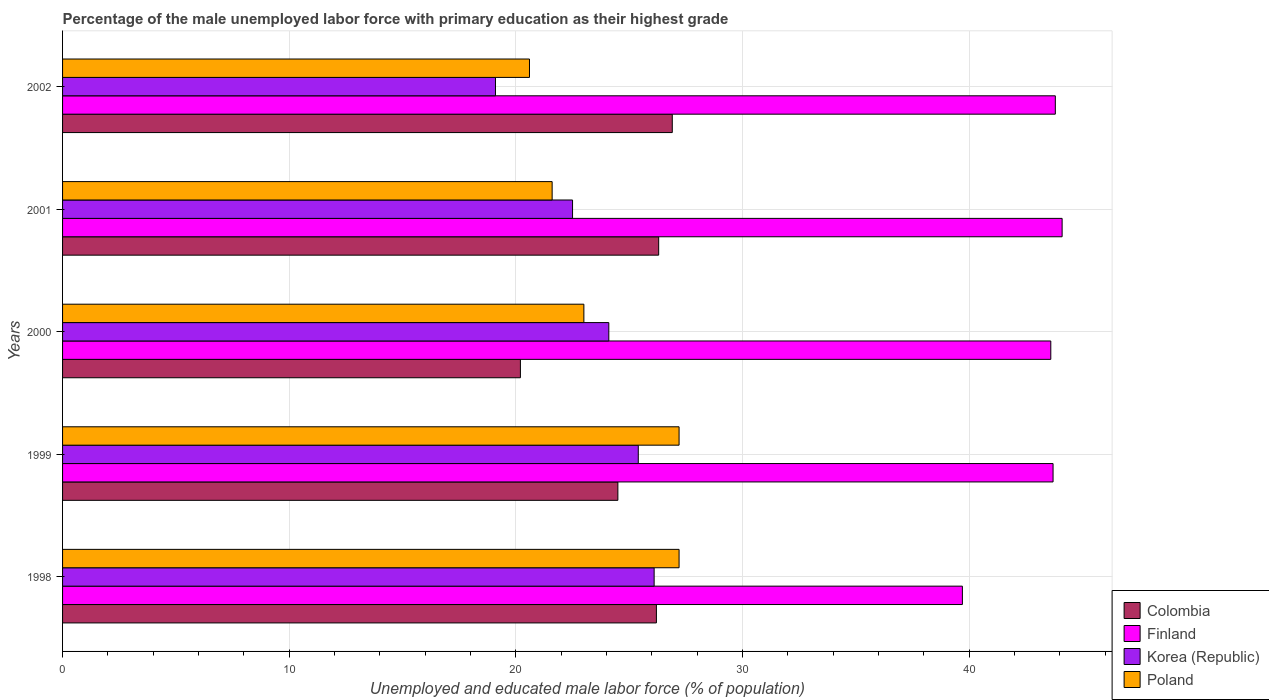Are the number of bars per tick equal to the number of legend labels?
Offer a terse response. Yes. Are the number of bars on each tick of the Y-axis equal?
Provide a succinct answer. Yes. How many bars are there on the 3rd tick from the top?
Your response must be concise. 4. What is the percentage of the unemployed male labor force with primary education in Korea (Republic) in 1998?
Provide a succinct answer. 26.1. Across all years, what is the maximum percentage of the unemployed male labor force with primary education in Finland?
Ensure brevity in your answer.  44.1. Across all years, what is the minimum percentage of the unemployed male labor force with primary education in Colombia?
Give a very brief answer. 20.2. What is the total percentage of the unemployed male labor force with primary education in Colombia in the graph?
Ensure brevity in your answer.  124.1. What is the difference between the percentage of the unemployed male labor force with primary education in Poland in 2000 and that in 2002?
Provide a succinct answer. 2.4. What is the difference between the percentage of the unemployed male labor force with primary education in Poland in 2000 and the percentage of the unemployed male labor force with primary education in Finland in 2002?
Your response must be concise. -20.8. What is the average percentage of the unemployed male labor force with primary education in Finland per year?
Provide a succinct answer. 42.98. In the year 2002, what is the difference between the percentage of the unemployed male labor force with primary education in Colombia and percentage of the unemployed male labor force with primary education in Finland?
Offer a terse response. -16.9. In how many years, is the percentage of the unemployed male labor force with primary education in Poland greater than 2 %?
Ensure brevity in your answer.  5. What is the ratio of the percentage of the unemployed male labor force with primary education in Poland in 1999 to that in 2002?
Your response must be concise. 1.32. Is the difference between the percentage of the unemployed male labor force with primary education in Colombia in 1999 and 2000 greater than the difference between the percentage of the unemployed male labor force with primary education in Finland in 1999 and 2000?
Offer a very short reply. Yes. What is the difference between the highest and the second highest percentage of the unemployed male labor force with primary education in Poland?
Your answer should be very brief. 0. What is the difference between the highest and the lowest percentage of the unemployed male labor force with primary education in Finland?
Your answer should be compact. 4.4. What does the 3rd bar from the bottom in 1998 represents?
Offer a very short reply. Korea (Republic). Is it the case that in every year, the sum of the percentage of the unemployed male labor force with primary education in Colombia and percentage of the unemployed male labor force with primary education in Korea (Republic) is greater than the percentage of the unemployed male labor force with primary education in Poland?
Your answer should be compact. Yes. How many bars are there?
Your answer should be compact. 20. Are all the bars in the graph horizontal?
Your answer should be compact. Yes. How many years are there in the graph?
Provide a succinct answer. 5. What is the difference between two consecutive major ticks on the X-axis?
Ensure brevity in your answer.  10. Does the graph contain any zero values?
Your answer should be compact. No. What is the title of the graph?
Your answer should be compact. Percentage of the male unemployed labor force with primary education as their highest grade. Does "Latvia" appear as one of the legend labels in the graph?
Make the answer very short. No. What is the label or title of the X-axis?
Make the answer very short. Unemployed and educated male labor force (% of population). What is the Unemployed and educated male labor force (% of population) in Colombia in 1998?
Provide a short and direct response. 26.2. What is the Unemployed and educated male labor force (% of population) in Finland in 1998?
Give a very brief answer. 39.7. What is the Unemployed and educated male labor force (% of population) in Korea (Republic) in 1998?
Keep it short and to the point. 26.1. What is the Unemployed and educated male labor force (% of population) in Poland in 1998?
Offer a very short reply. 27.2. What is the Unemployed and educated male labor force (% of population) of Finland in 1999?
Your response must be concise. 43.7. What is the Unemployed and educated male labor force (% of population) in Korea (Republic) in 1999?
Your answer should be very brief. 25.4. What is the Unemployed and educated male labor force (% of population) in Poland in 1999?
Your answer should be very brief. 27.2. What is the Unemployed and educated male labor force (% of population) of Colombia in 2000?
Provide a short and direct response. 20.2. What is the Unemployed and educated male labor force (% of population) of Finland in 2000?
Offer a terse response. 43.6. What is the Unemployed and educated male labor force (% of population) in Korea (Republic) in 2000?
Make the answer very short. 24.1. What is the Unemployed and educated male labor force (% of population) in Colombia in 2001?
Your answer should be compact. 26.3. What is the Unemployed and educated male labor force (% of population) in Finland in 2001?
Keep it short and to the point. 44.1. What is the Unemployed and educated male labor force (% of population) of Korea (Republic) in 2001?
Give a very brief answer. 22.5. What is the Unemployed and educated male labor force (% of population) in Poland in 2001?
Your response must be concise. 21.6. What is the Unemployed and educated male labor force (% of population) of Colombia in 2002?
Your answer should be very brief. 26.9. What is the Unemployed and educated male labor force (% of population) in Finland in 2002?
Your answer should be very brief. 43.8. What is the Unemployed and educated male labor force (% of population) in Korea (Republic) in 2002?
Your answer should be very brief. 19.1. What is the Unemployed and educated male labor force (% of population) of Poland in 2002?
Keep it short and to the point. 20.6. Across all years, what is the maximum Unemployed and educated male labor force (% of population) of Colombia?
Offer a terse response. 26.9. Across all years, what is the maximum Unemployed and educated male labor force (% of population) of Finland?
Offer a very short reply. 44.1. Across all years, what is the maximum Unemployed and educated male labor force (% of population) in Korea (Republic)?
Provide a succinct answer. 26.1. Across all years, what is the maximum Unemployed and educated male labor force (% of population) of Poland?
Your answer should be compact. 27.2. Across all years, what is the minimum Unemployed and educated male labor force (% of population) of Colombia?
Provide a succinct answer. 20.2. Across all years, what is the minimum Unemployed and educated male labor force (% of population) in Finland?
Make the answer very short. 39.7. Across all years, what is the minimum Unemployed and educated male labor force (% of population) of Korea (Republic)?
Ensure brevity in your answer.  19.1. Across all years, what is the minimum Unemployed and educated male labor force (% of population) of Poland?
Your answer should be compact. 20.6. What is the total Unemployed and educated male labor force (% of population) in Colombia in the graph?
Provide a succinct answer. 124.1. What is the total Unemployed and educated male labor force (% of population) in Finland in the graph?
Give a very brief answer. 214.9. What is the total Unemployed and educated male labor force (% of population) of Korea (Republic) in the graph?
Offer a terse response. 117.2. What is the total Unemployed and educated male labor force (% of population) of Poland in the graph?
Provide a succinct answer. 119.6. What is the difference between the Unemployed and educated male labor force (% of population) in Korea (Republic) in 1998 and that in 1999?
Give a very brief answer. 0.7. What is the difference between the Unemployed and educated male labor force (% of population) of Poland in 1998 and that in 1999?
Your answer should be compact. 0. What is the difference between the Unemployed and educated male labor force (% of population) of Colombia in 1998 and that in 2000?
Your answer should be compact. 6. What is the difference between the Unemployed and educated male labor force (% of population) in Korea (Republic) in 1998 and that in 2000?
Provide a succinct answer. 2. What is the difference between the Unemployed and educated male labor force (% of population) in Poland in 1998 and that in 2000?
Your answer should be very brief. 4.2. What is the difference between the Unemployed and educated male labor force (% of population) of Colombia in 1998 and that in 2001?
Ensure brevity in your answer.  -0.1. What is the difference between the Unemployed and educated male labor force (% of population) in Finland in 1998 and that in 2001?
Your answer should be very brief. -4.4. What is the difference between the Unemployed and educated male labor force (% of population) in Korea (Republic) in 1998 and that in 2001?
Offer a terse response. 3.6. What is the difference between the Unemployed and educated male labor force (% of population) of Poland in 1998 and that in 2001?
Make the answer very short. 5.6. What is the difference between the Unemployed and educated male labor force (% of population) of Poland in 1998 and that in 2002?
Provide a short and direct response. 6.6. What is the difference between the Unemployed and educated male labor force (% of population) of Finland in 1999 and that in 2000?
Provide a succinct answer. 0.1. What is the difference between the Unemployed and educated male labor force (% of population) in Colombia in 1999 and that in 2001?
Keep it short and to the point. -1.8. What is the difference between the Unemployed and educated male labor force (% of population) in Poland in 1999 and that in 2001?
Your response must be concise. 5.6. What is the difference between the Unemployed and educated male labor force (% of population) in Korea (Republic) in 1999 and that in 2002?
Your answer should be very brief. 6.3. What is the difference between the Unemployed and educated male labor force (% of population) in Colombia in 2000 and that in 2001?
Give a very brief answer. -6.1. What is the difference between the Unemployed and educated male labor force (% of population) of Finland in 2000 and that in 2001?
Keep it short and to the point. -0.5. What is the difference between the Unemployed and educated male labor force (% of population) of Poland in 2000 and that in 2001?
Offer a very short reply. 1.4. What is the difference between the Unemployed and educated male labor force (% of population) in Colombia in 2000 and that in 2002?
Ensure brevity in your answer.  -6.7. What is the difference between the Unemployed and educated male labor force (% of population) in Poland in 2001 and that in 2002?
Your response must be concise. 1. What is the difference between the Unemployed and educated male labor force (% of population) in Colombia in 1998 and the Unemployed and educated male labor force (% of population) in Finland in 1999?
Your answer should be compact. -17.5. What is the difference between the Unemployed and educated male labor force (% of population) of Colombia in 1998 and the Unemployed and educated male labor force (% of population) of Korea (Republic) in 1999?
Make the answer very short. 0.8. What is the difference between the Unemployed and educated male labor force (% of population) of Finland in 1998 and the Unemployed and educated male labor force (% of population) of Korea (Republic) in 1999?
Your answer should be compact. 14.3. What is the difference between the Unemployed and educated male labor force (% of population) of Finland in 1998 and the Unemployed and educated male labor force (% of population) of Poland in 1999?
Give a very brief answer. 12.5. What is the difference between the Unemployed and educated male labor force (% of population) of Korea (Republic) in 1998 and the Unemployed and educated male labor force (% of population) of Poland in 1999?
Give a very brief answer. -1.1. What is the difference between the Unemployed and educated male labor force (% of population) of Colombia in 1998 and the Unemployed and educated male labor force (% of population) of Finland in 2000?
Offer a terse response. -17.4. What is the difference between the Unemployed and educated male labor force (% of population) in Colombia in 1998 and the Unemployed and educated male labor force (% of population) in Korea (Republic) in 2000?
Offer a terse response. 2.1. What is the difference between the Unemployed and educated male labor force (% of population) in Colombia in 1998 and the Unemployed and educated male labor force (% of population) in Poland in 2000?
Keep it short and to the point. 3.2. What is the difference between the Unemployed and educated male labor force (% of population) of Finland in 1998 and the Unemployed and educated male labor force (% of population) of Korea (Republic) in 2000?
Provide a short and direct response. 15.6. What is the difference between the Unemployed and educated male labor force (% of population) in Finland in 1998 and the Unemployed and educated male labor force (% of population) in Poland in 2000?
Give a very brief answer. 16.7. What is the difference between the Unemployed and educated male labor force (% of population) in Korea (Republic) in 1998 and the Unemployed and educated male labor force (% of population) in Poland in 2000?
Keep it short and to the point. 3.1. What is the difference between the Unemployed and educated male labor force (% of population) of Colombia in 1998 and the Unemployed and educated male labor force (% of population) of Finland in 2001?
Make the answer very short. -17.9. What is the difference between the Unemployed and educated male labor force (% of population) of Colombia in 1998 and the Unemployed and educated male labor force (% of population) of Korea (Republic) in 2001?
Your answer should be compact. 3.7. What is the difference between the Unemployed and educated male labor force (% of population) of Finland in 1998 and the Unemployed and educated male labor force (% of population) of Korea (Republic) in 2001?
Give a very brief answer. 17.2. What is the difference between the Unemployed and educated male labor force (% of population) in Colombia in 1998 and the Unemployed and educated male labor force (% of population) in Finland in 2002?
Your answer should be compact. -17.6. What is the difference between the Unemployed and educated male labor force (% of population) in Colombia in 1998 and the Unemployed and educated male labor force (% of population) in Poland in 2002?
Keep it short and to the point. 5.6. What is the difference between the Unemployed and educated male labor force (% of population) in Finland in 1998 and the Unemployed and educated male labor force (% of population) in Korea (Republic) in 2002?
Offer a very short reply. 20.6. What is the difference between the Unemployed and educated male labor force (% of population) in Finland in 1998 and the Unemployed and educated male labor force (% of population) in Poland in 2002?
Keep it short and to the point. 19.1. What is the difference between the Unemployed and educated male labor force (% of population) in Korea (Republic) in 1998 and the Unemployed and educated male labor force (% of population) in Poland in 2002?
Make the answer very short. 5.5. What is the difference between the Unemployed and educated male labor force (% of population) of Colombia in 1999 and the Unemployed and educated male labor force (% of population) of Finland in 2000?
Ensure brevity in your answer.  -19.1. What is the difference between the Unemployed and educated male labor force (% of population) in Colombia in 1999 and the Unemployed and educated male labor force (% of population) in Korea (Republic) in 2000?
Ensure brevity in your answer.  0.4. What is the difference between the Unemployed and educated male labor force (% of population) in Finland in 1999 and the Unemployed and educated male labor force (% of population) in Korea (Republic) in 2000?
Offer a very short reply. 19.6. What is the difference between the Unemployed and educated male labor force (% of population) of Finland in 1999 and the Unemployed and educated male labor force (% of population) of Poland in 2000?
Offer a terse response. 20.7. What is the difference between the Unemployed and educated male labor force (% of population) of Korea (Republic) in 1999 and the Unemployed and educated male labor force (% of population) of Poland in 2000?
Make the answer very short. 2.4. What is the difference between the Unemployed and educated male labor force (% of population) of Colombia in 1999 and the Unemployed and educated male labor force (% of population) of Finland in 2001?
Provide a short and direct response. -19.6. What is the difference between the Unemployed and educated male labor force (% of population) of Colombia in 1999 and the Unemployed and educated male labor force (% of population) of Poland in 2001?
Offer a very short reply. 2.9. What is the difference between the Unemployed and educated male labor force (% of population) of Finland in 1999 and the Unemployed and educated male labor force (% of population) of Korea (Republic) in 2001?
Make the answer very short. 21.2. What is the difference between the Unemployed and educated male labor force (% of population) in Finland in 1999 and the Unemployed and educated male labor force (% of population) in Poland in 2001?
Your response must be concise. 22.1. What is the difference between the Unemployed and educated male labor force (% of population) of Colombia in 1999 and the Unemployed and educated male labor force (% of population) of Finland in 2002?
Provide a short and direct response. -19.3. What is the difference between the Unemployed and educated male labor force (% of population) of Colombia in 1999 and the Unemployed and educated male labor force (% of population) of Korea (Republic) in 2002?
Keep it short and to the point. 5.4. What is the difference between the Unemployed and educated male labor force (% of population) of Finland in 1999 and the Unemployed and educated male labor force (% of population) of Korea (Republic) in 2002?
Make the answer very short. 24.6. What is the difference between the Unemployed and educated male labor force (% of population) in Finland in 1999 and the Unemployed and educated male labor force (% of population) in Poland in 2002?
Ensure brevity in your answer.  23.1. What is the difference between the Unemployed and educated male labor force (% of population) in Korea (Republic) in 1999 and the Unemployed and educated male labor force (% of population) in Poland in 2002?
Provide a succinct answer. 4.8. What is the difference between the Unemployed and educated male labor force (% of population) of Colombia in 2000 and the Unemployed and educated male labor force (% of population) of Finland in 2001?
Provide a short and direct response. -23.9. What is the difference between the Unemployed and educated male labor force (% of population) in Colombia in 2000 and the Unemployed and educated male labor force (% of population) in Korea (Republic) in 2001?
Your response must be concise. -2.3. What is the difference between the Unemployed and educated male labor force (% of population) in Colombia in 2000 and the Unemployed and educated male labor force (% of population) in Poland in 2001?
Give a very brief answer. -1.4. What is the difference between the Unemployed and educated male labor force (% of population) in Finland in 2000 and the Unemployed and educated male labor force (% of population) in Korea (Republic) in 2001?
Your response must be concise. 21.1. What is the difference between the Unemployed and educated male labor force (% of population) in Finland in 2000 and the Unemployed and educated male labor force (% of population) in Poland in 2001?
Your answer should be very brief. 22. What is the difference between the Unemployed and educated male labor force (% of population) of Korea (Republic) in 2000 and the Unemployed and educated male labor force (% of population) of Poland in 2001?
Give a very brief answer. 2.5. What is the difference between the Unemployed and educated male labor force (% of population) in Colombia in 2000 and the Unemployed and educated male labor force (% of population) in Finland in 2002?
Offer a terse response. -23.6. What is the difference between the Unemployed and educated male labor force (% of population) of Colombia in 2001 and the Unemployed and educated male labor force (% of population) of Finland in 2002?
Your answer should be compact. -17.5. What is the difference between the Unemployed and educated male labor force (% of population) of Colombia in 2001 and the Unemployed and educated male labor force (% of population) of Poland in 2002?
Make the answer very short. 5.7. What is the difference between the Unemployed and educated male labor force (% of population) of Finland in 2001 and the Unemployed and educated male labor force (% of population) of Korea (Republic) in 2002?
Offer a terse response. 25. What is the average Unemployed and educated male labor force (% of population) in Colombia per year?
Ensure brevity in your answer.  24.82. What is the average Unemployed and educated male labor force (% of population) in Finland per year?
Provide a short and direct response. 42.98. What is the average Unemployed and educated male labor force (% of population) in Korea (Republic) per year?
Give a very brief answer. 23.44. What is the average Unemployed and educated male labor force (% of population) of Poland per year?
Give a very brief answer. 23.92. In the year 1998, what is the difference between the Unemployed and educated male labor force (% of population) of Colombia and Unemployed and educated male labor force (% of population) of Poland?
Offer a terse response. -1. In the year 1998, what is the difference between the Unemployed and educated male labor force (% of population) of Finland and Unemployed and educated male labor force (% of population) of Poland?
Your answer should be very brief. 12.5. In the year 1999, what is the difference between the Unemployed and educated male labor force (% of population) of Colombia and Unemployed and educated male labor force (% of population) of Finland?
Your answer should be very brief. -19.2. In the year 1999, what is the difference between the Unemployed and educated male labor force (% of population) of Colombia and Unemployed and educated male labor force (% of population) of Korea (Republic)?
Your answer should be very brief. -0.9. In the year 1999, what is the difference between the Unemployed and educated male labor force (% of population) of Finland and Unemployed and educated male labor force (% of population) of Korea (Republic)?
Offer a terse response. 18.3. In the year 2000, what is the difference between the Unemployed and educated male labor force (% of population) in Colombia and Unemployed and educated male labor force (% of population) in Finland?
Your response must be concise. -23.4. In the year 2000, what is the difference between the Unemployed and educated male labor force (% of population) of Colombia and Unemployed and educated male labor force (% of population) of Korea (Republic)?
Offer a very short reply. -3.9. In the year 2000, what is the difference between the Unemployed and educated male labor force (% of population) in Colombia and Unemployed and educated male labor force (% of population) in Poland?
Keep it short and to the point. -2.8. In the year 2000, what is the difference between the Unemployed and educated male labor force (% of population) in Finland and Unemployed and educated male labor force (% of population) in Korea (Republic)?
Provide a short and direct response. 19.5. In the year 2000, what is the difference between the Unemployed and educated male labor force (% of population) of Finland and Unemployed and educated male labor force (% of population) of Poland?
Ensure brevity in your answer.  20.6. In the year 2001, what is the difference between the Unemployed and educated male labor force (% of population) in Colombia and Unemployed and educated male labor force (% of population) in Finland?
Provide a succinct answer. -17.8. In the year 2001, what is the difference between the Unemployed and educated male labor force (% of population) of Finland and Unemployed and educated male labor force (% of population) of Korea (Republic)?
Provide a succinct answer. 21.6. In the year 2001, what is the difference between the Unemployed and educated male labor force (% of population) in Korea (Republic) and Unemployed and educated male labor force (% of population) in Poland?
Provide a succinct answer. 0.9. In the year 2002, what is the difference between the Unemployed and educated male labor force (% of population) of Colombia and Unemployed and educated male labor force (% of population) of Finland?
Ensure brevity in your answer.  -16.9. In the year 2002, what is the difference between the Unemployed and educated male labor force (% of population) in Colombia and Unemployed and educated male labor force (% of population) in Korea (Republic)?
Your response must be concise. 7.8. In the year 2002, what is the difference between the Unemployed and educated male labor force (% of population) of Finland and Unemployed and educated male labor force (% of population) of Korea (Republic)?
Your answer should be very brief. 24.7. In the year 2002, what is the difference between the Unemployed and educated male labor force (% of population) of Finland and Unemployed and educated male labor force (% of population) of Poland?
Your answer should be compact. 23.2. What is the ratio of the Unemployed and educated male labor force (% of population) of Colombia in 1998 to that in 1999?
Provide a short and direct response. 1.07. What is the ratio of the Unemployed and educated male labor force (% of population) of Finland in 1998 to that in 1999?
Give a very brief answer. 0.91. What is the ratio of the Unemployed and educated male labor force (% of population) in Korea (Republic) in 1998 to that in 1999?
Offer a very short reply. 1.03. What is the ratio of the Unemployed and educated male labor force (% of population) of Poland in 1998 to that in 1999?
Offer a very short reply. 1. What is the ratio of the Unemployed and educated male labor force (% of population) of Colombia in 1998 to that in 2000?
Give a very brief answer. 1.3. What is the ratio of the Unemployed and educated male labor force (% of population) of Finland in 1998 to that in 2000?
Offer a terse response. 0.91. What is the ratio of the Unemployed and educated male labor force (% of population) of Korea (Republic) in 1998 to that in 2000?
Make the answer very short. 1.08. What is the ratio of the Unemployed and educated male labor force (% of population) of Poland in 1998 to that in 2000?
Provide a short and direct response. 1.18. What is the ratio of the Unemployed and educated male labor force (% of population) in Finland in 1998 to that in 2001?
Provide a short and direct response. 0.9. What is the ratio of the Unemployed and educated male labor force (% of population) of Korea (Republic) in 1998 to that in 2001?
Provide a short and direct response. 1.16. What is the ratio of the Unemployed and educated male labor force (% of population) in Poland in 1998 to that in 2001?
Your response must be concise. 1.26. What is the ratio of the Unemployed and educated male labor force (% of population) in Colombia in 1998 to that in 2002?
Offer a very short reply. 0.97. What is the ratio of the Unemployed and educated male labor force (% of population) of Finland in 1998 to that in 2002?
Ensure brevity in your answer.  0.91. What is the ratio of the Unemployed and educated male labor force (% of population) in Korea (Republic) in 1998 to that in 2002?
Offer a terse response. 1.37. What is the ratio of the Unemployed and educated male labor force (% of population) of Poland in 1998 to that in 2002?
Give a very brief answer. 1.32. What is the ratio of the Unemployed and educated male labor force (% of population) in Colombia in 1999 to that in 2000?
Provide a succinct answer. 1.21. What is the ratio of the Unemployed and educated male labor force (% of population) in Finland in 1999 to that in 2000?
Make the answer very short. 1. What is the ratio of the Unemployed and educated male labor force (% of population) in Korea (Republic) in 1999 to that in 2000?
Provide a succinct answer. 1.05. What is the ratio of the Unemployed and educated male labor force (% of population) in Poland in 1999 to that in 2000?
Offer a terse response. 1.18. What is the ratio of the Unemployed and educated male labor force (% of population) of Colombia in 1999 to that in 2001?
Offer a very short reply. 0.93. What is the ratio of the Unemployed and educated male labor force (% of population) in Finland in 1999 to that in 2001?
Ensure brevity in your answer.  0.99. What is the ratio of the Unemployed and educated male labor force (% of population) in Korea (Republic) in 1999 to that in 2001?
Your answer should be compact. 1.13. What is the ratio of the Unemployed and educated male labor force (% of population) of Poland in 1999 to that in 2001?
Provide a short and direct response. 1.26. What is the ratio of the Unemployed and educated male labor force (% of population) in Colombia in 1999 to that in 2002?
Give a very brief answer. 0.91. What is the ratio of the Unemployed and educated male labor force (% of population) in Finland in 1999 to that in 2002?
Provide a succinct answer. 1. What is the ratio of the Unemployed and educated male labor force (% of population) of Korea (Republic) in 1999 to that in 2002?
Keep it short and to the point. 1.33. What is the ratio of the Unemployed and educated male labor force (% of population) in Poland in 1999 to that in 2002?
Offer a terse response. 1.32. What is the ratio of the Unemployed and educated male labor force (% of population) in Colombia in 2000 to that in 2001?
Your answer should be compact. 0.77. What is the ratio of the Unemployed and educated male labor force (% of population) in Finland in 2000 to that in 2001?
Your answer should be very brief. 0.99. What is the ratio of the Unemployed and educated male labor force (% of population) in Korea (Republic) in 2000 to that in 2001?
Provide a short and direct response. 1.07. What is the ratio of the Unemployed and educated male labor force (% of population) of Poland in 2000 to that in 2001?
Your answer should be compact. 1.06. What is the ratio of the Unemployed and educated male labor force (% of population) of Colombia in 2000 to that in 2002?
Give a very brief answer. 0.75. What is the ratio of the Unemployed and educated male labor force (% of population) of Korea (Republic) in 2000 to that in 2002?
Give a very brief answer. 1.26. What is the ratio of the Unemployed and educated male labor force (% of population) of Poland in 2000 to that in 2002?
Your response must be concise. 1.12. What is the ratio of the Unemployed and educated male labor force (% of population) of Colombia in 2001 to that in 2002?
Give a very brief answer. 0.98. What is the ratio of the Unemployed and educated male labor force (% of population) of Finland in 2001 to that in 2002?
Provide a succinct answer. 1.01. What is the ratio of the Unemployed and educated male labor force (% of population) in Korea (Republic) in 2001 to that in 2002?
Keep it short and to the point. 1.18. What is the ratio of the Unemployed and educated male labor force (% of population) in Poland in 2001 to that in 2002?
Your answer should be compact. 1.05. What is the difference between the highest and the second highest Unemployed and educated male labor force (% of population) of Finland?
Make the answer very short. 0.3. What is the difference between the highest and the lowest Unemployed and educated male labor force (% of population) of Korea (Republic)?
Give a very brief answer. 7. What is the difference between the highest and the lowest Unemployed and educated male labor force (% of population) of Poland?
Provide a short and direct response. 6.6. 